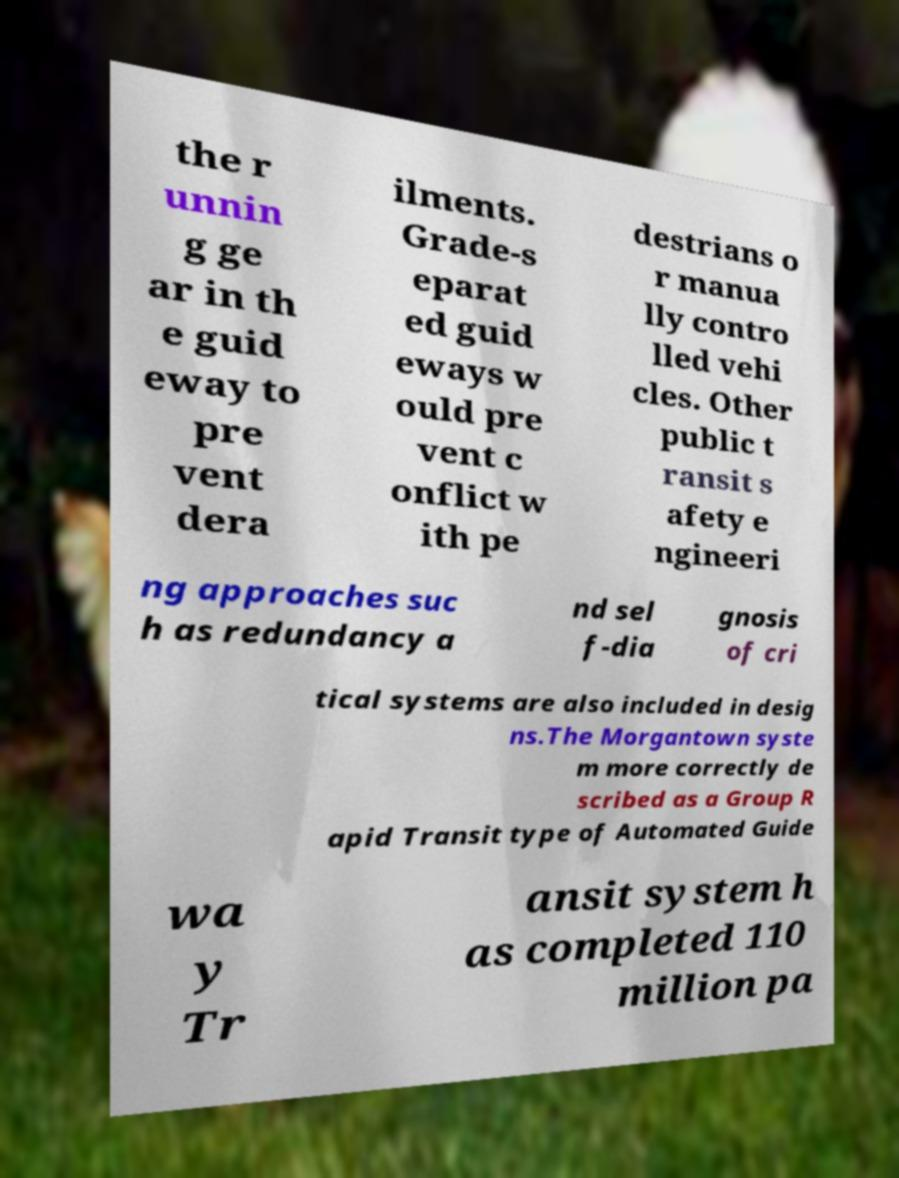Can you read and provide the text displayed in the image?This photo seems to have some interesting text. Can you extract and type it out for me? the r unnin g ge ar in th e guid eway to pre vent dera ilments. Grade-s eparat ed guid eways w ould pre vent c onflict w ith pe destrians o r manua lly contro lled vehi cles. Other public t ransit s afety e ngineeri ng approaches suc h as redundancy a nd sel f-dia gnosis of cri tical systems are also included in desig ns.The Morgantown syste m more correctly de scribed as a Group R apid Transit type of Automated Guide wa y Tr ansit system h as completed 110 million pa 